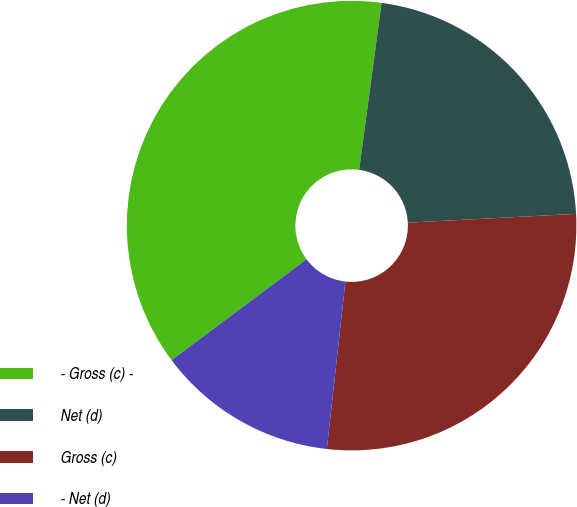Convert chart. <chart><loc_0><loc_0><loc_500><loc_500><pie_chart><fcel>- Gross (c) -<fcel>Net (d)<fcel>Gross (c)<fcel>- Net (d)<nl><fcel>37.34%<fcel>22.04%<fcel>27.59%<fcel>13.03%<nl></chart> 